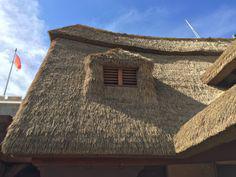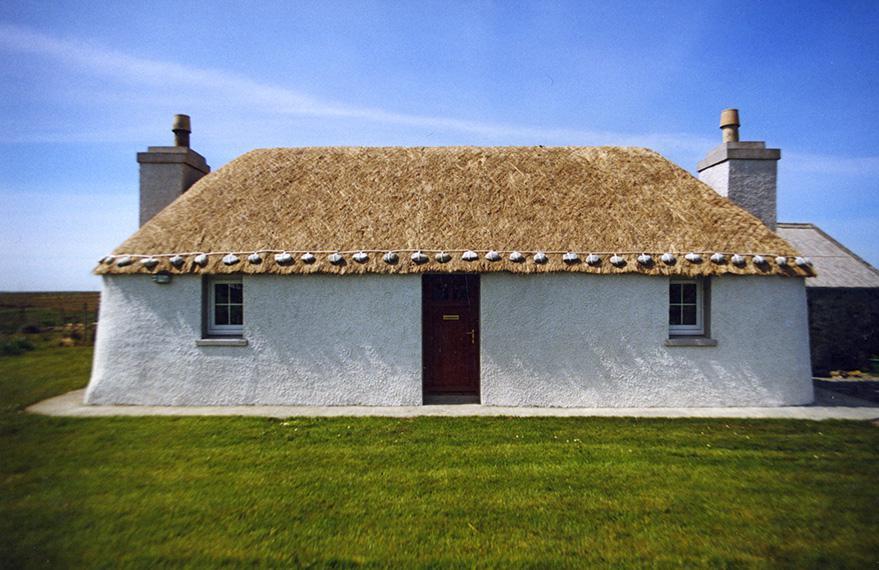The first image is the image on the left, the second image is the image on the right. Given the left and right images, does the statement "One image shows a rectangular white building with a single window flanking each side of the door, a chimney on each end, and a roof with a straight bottom edge bordered with a dotted line of stones." hold true? Answer yes or no. Yes. The first image is the image on the left, the second image is the image on the right. Analyze the images presented: Is the assertion "In at least one image there is a white house with two windows, a straw roof and two chimneys." valid? Answer yes or no. Yes. 